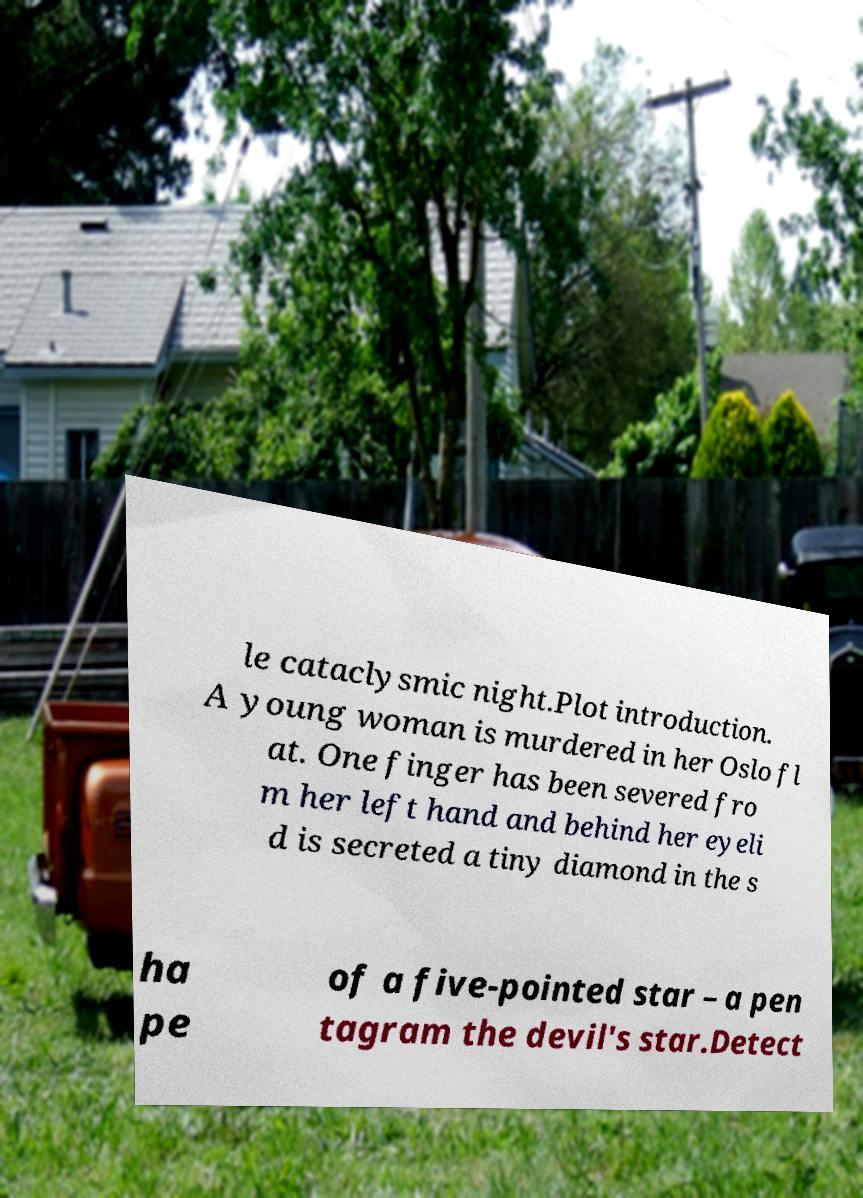What messages or text are displayed in this image? I need them in a readable, typed format. le cataclysmic night.Plot introduction. A young woman is murdered in her Oslo fl at. One finger has been severed fro m her left hand and behind her eyeli d is secreted a tiny diamond in the s ha pe of a five-pointed star – a pen tagram the devil's star.Detect 